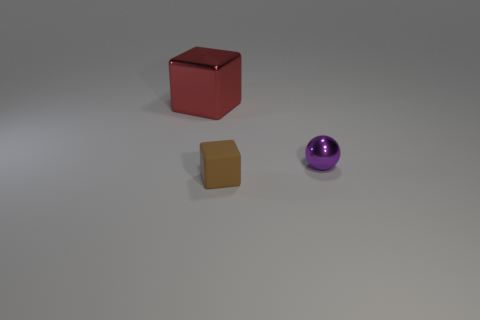Are there any other things that are the same size as the shiny cube?
Offer a very short reply. No. There is a metallic object to the left of the brown thing; what color is it?
Provide a succinct answer. Red. There is a cube behind the object right of the cube that is in front of the large red metallic thing; what is its material?
Give a very brief answer. Metal. There is a cube that is right of the shiny thing on the left side of the purple ball; how big is it?
Provide a short and direct response. Small. What color is the large shiny thing that is the same shape as the small brown rubber thing?
Ensure brevity in your answer.  Red. Is the brown cube the same size as the red shiny cube?
Ensure brevity in your answer.  No. What material is the purple ball?
Give a very brief answer. Metal. What is the color of the small ball that is made of the same material as the big cube?
Give a very brief answer. Purple. Are the big red object and the small object that is on the right side of the brown object made of the same material?
Provide a short and direct response. Yes. How many red things have the same material as the brown object?
Your answer should be very brief. 0. 